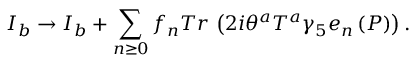<formula> <loc_0><loc_0><loc_500><loc_500>I _ { b } \rightarrow I _ { b } + \sum _ { n \geq 0 } f _ { n } T r \, \left ( 2 i \theta ^ { a } T ^ { a } \gamma _ { 5 } e _ { n } \left ( P \right ) \right ) .</formula> 